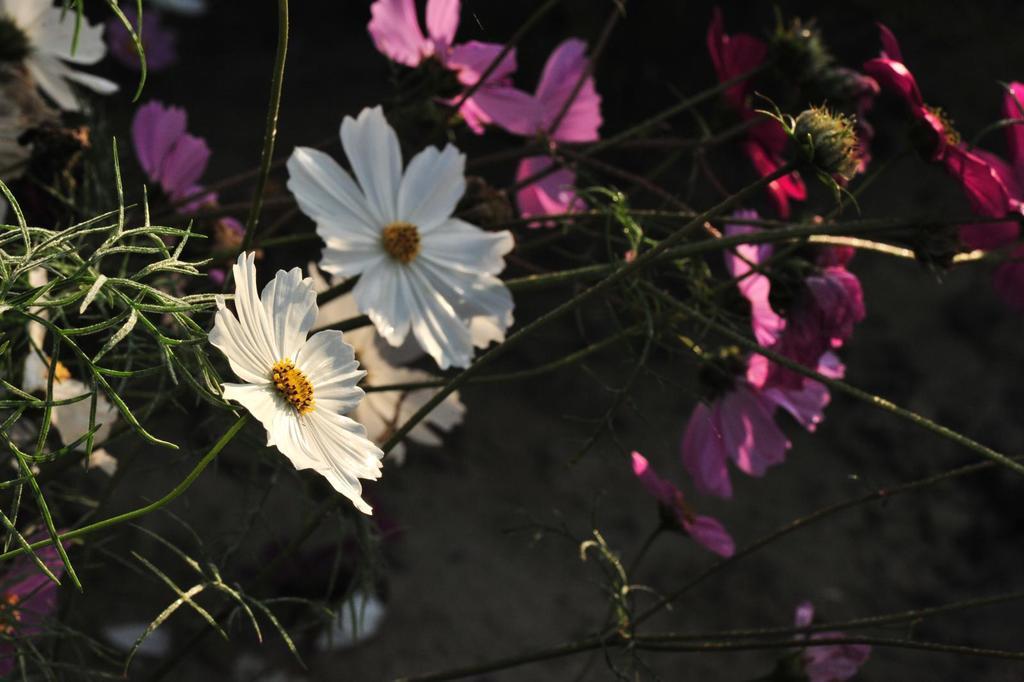Can you describe this image briefly? In this image we can see different color flowers on stems. In the background it is dark. 